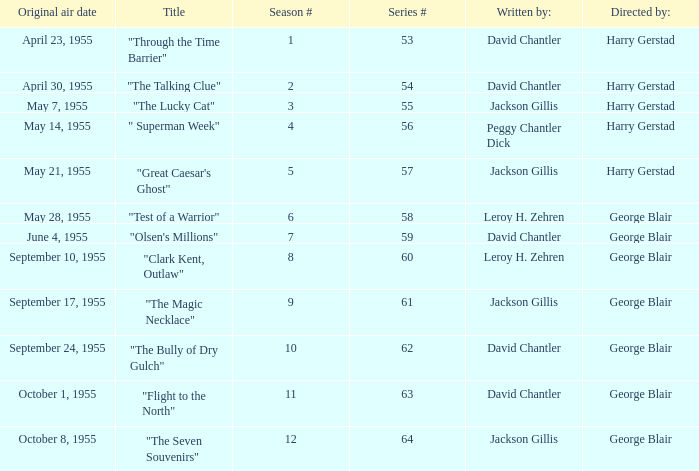Which Season originally aired on September 17, 1955 9.0. 